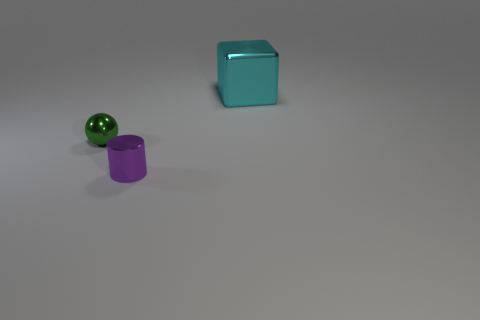How many green metal things have the same size as the cylinder?
Offer a terse response. 1. What number of blue objects are either blocks or metal objects?
Your answer should be compact. 0. What number of things are either tiny green shiny spheres or things left of the cyan cube?
Keep it short and to the point. 2. What is the material of the thing that is in front of the green sphere?
Your answer should be very brief. Metal. There is a shiny thing that is the same size as the metallic cylinder; what is its shape?
Offer a terse response. Sphere. Are there any other things of the same shape as the cyan object?
Keep it short and to the point. No. Are the small green ball and the thing that is to the right of the small purple metal cylinder made of the same material?
Ensure brevity in your answer.  Yes. There is a thing that is to the right of the small object that is on the right side of the green shiny object; what is it made of?
Ensure brevity in your answer.  Metal. Are there more tiny purple metal cylinders that are behind the big thing than small green metallic balls?
Provide a succinct answer. No. Is there a tiny green metal object?
Offer a terse response. Yes. 